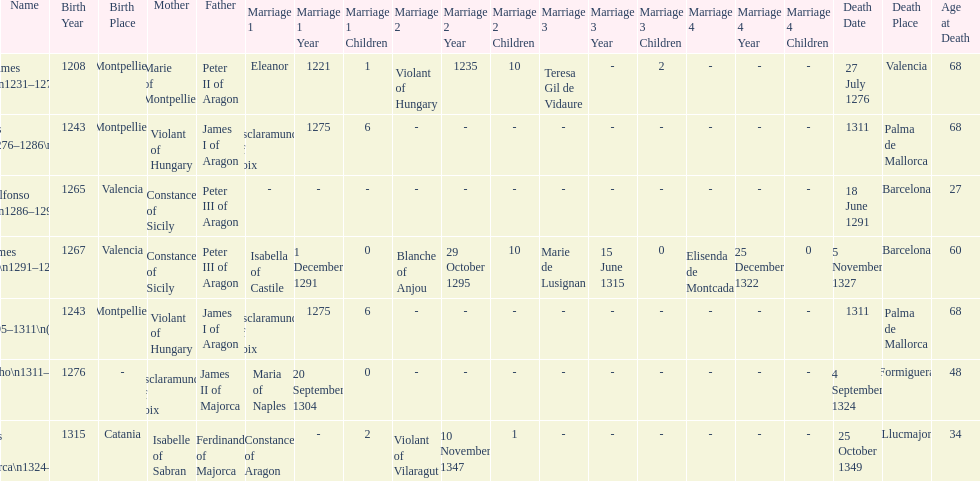How many total marriages did james i have? 3. 